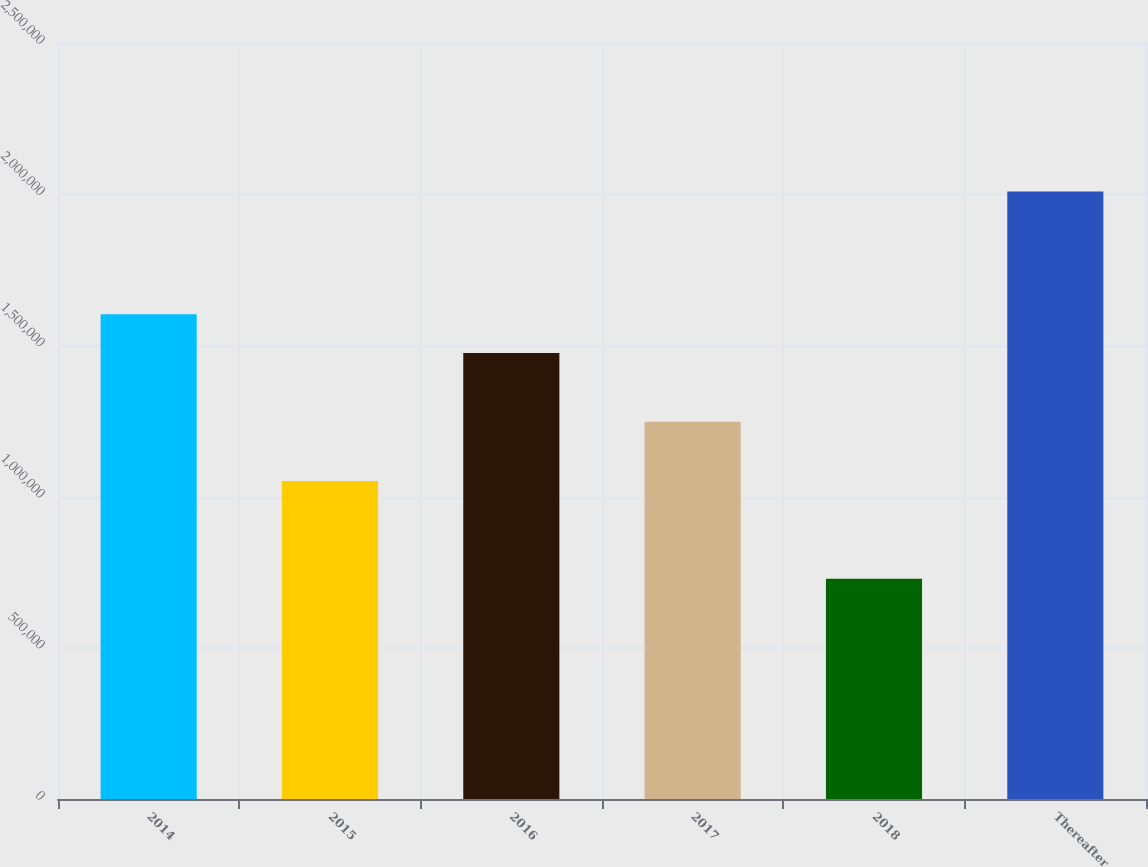Convert chart. <chart><loc_0><loc_0><loc_500><loc_500><bar_chart><fcel>2014<fcel>2015<fcel>2016<fcel>2017<fcel>2018<fcel>Thereafter<nl><fcel>1.60292e+06<fcel>1.05191e+06<fcel>1.47483e+06<fcel>1.24716e+06<fcel>728276<fcel>2.00925e+06<nl></chart> 